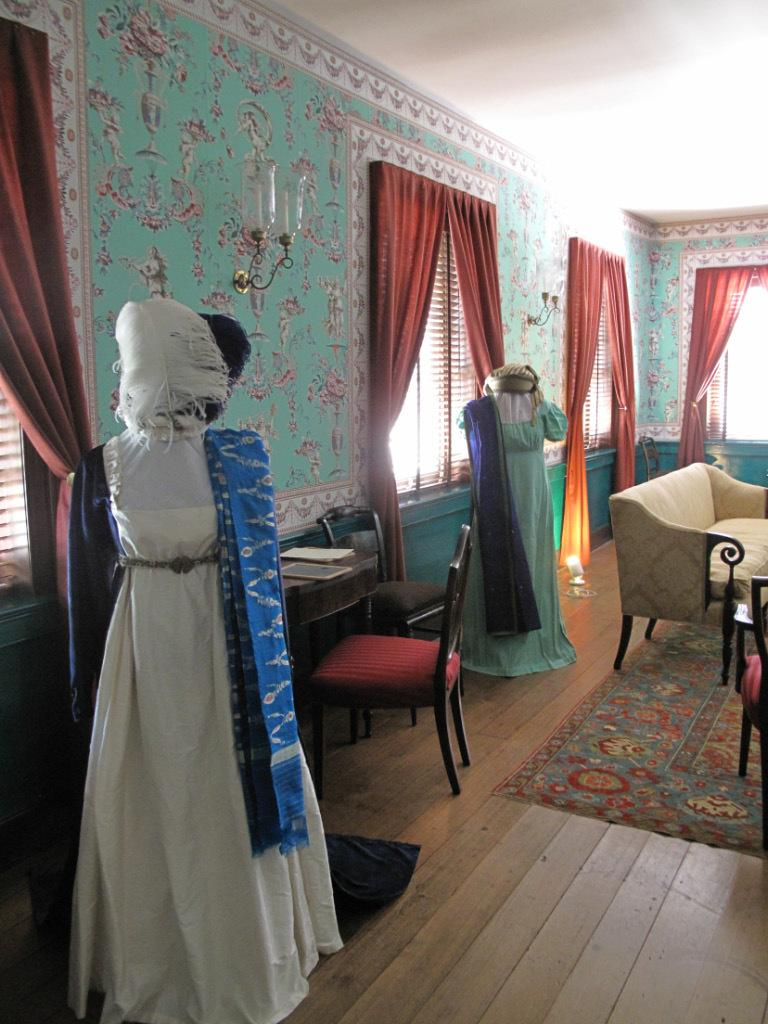What is the main subject in the image? There is a woman standing in the image. What type of furniture can be seen in the image? There are chairs and a couch in the image. Where is the window located in the image? There is a window on the right side of the image. What is associated with the window in the image? There is a curtain associated with the window. What can be seen in the image that provides light? There are lights visible in the image. What type of ornament is hanging from the ceiling in the image? There is no ornament hanging from the ceiling in the image. What force is being applied to the woman in the image? There is no force being applied to the woman in the image; she is standing still. 